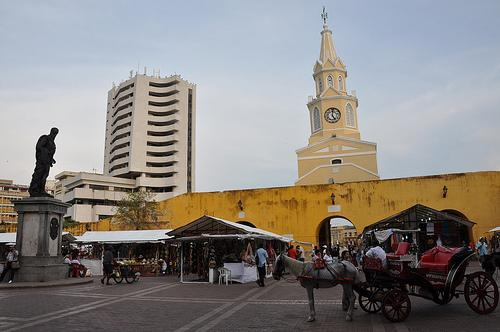Discuss the overall sentiment of the image. The overall sentiment of the image is positive and lively, with various objects, animals, and people interacting within an outdoor environment with a clear sky. How many buildings are mentioned in the image descriptions? There are three buildings mentioned: A tall white building, a multi-floored building, and a very tall building with curved windows. Comment on the sky and clouds in the image. There are several white clouds in the blue sky, spread across different areas within the sky, with varying sizes and shapes. 